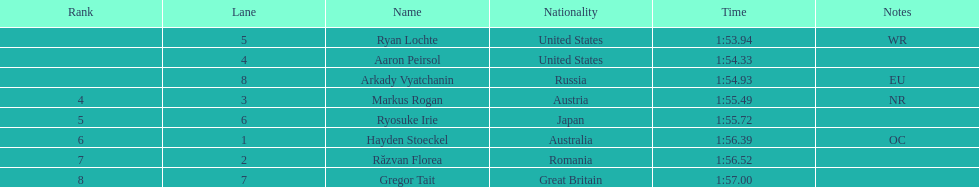Was austria or russia positioned higher? Russia. 